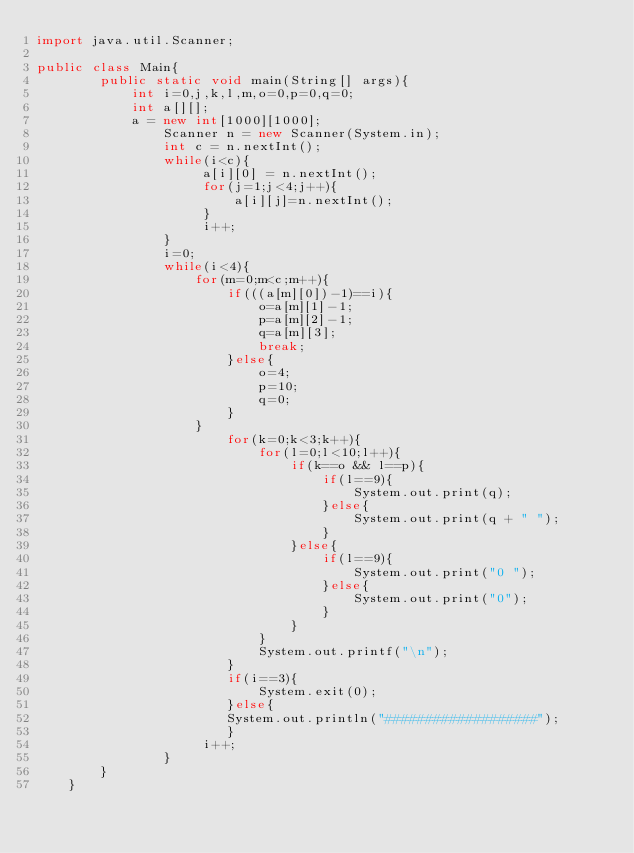Convert code to text. <code><loc_0><loc_0><loc_500><loc_500><_Java_>import java.util.Scanner;

public class Main{ 
        public static void main(String[] args){
            int i=0,j,k,l,m,o=0,p=0,q=0;
            int a[][];
            a = new int[1000][1000];
                Scanner n = new Scanner(System.in);
                int c = n.nextInt();
                while(i<c){
                     a[i][0] = n.nextInt();
                     for(j=1;j<4;j++){
                         a[i][j]=n.nextInt();
                     }
                     i++;
                }
                i=0;
                while(i<4){
                    for(m=0;m<c;m++){
                        if(((a[m][0])-1)==i){
                            o=a[m][1]-1;
                            p=a[m][2]-1;
                            q=a[m][3];
                            break;
                        }else{
                            o=4;
                            p=10;
                            q=0;
                        }
                    }
                        for(k=0;k<3;k++){
                            for(l=0;l<10;l++){
                                if(k==o && l==p){
                                    if(l==9){
                                        System.out.print(q);
                                    }else{
                                        System.out.print(q + " ");
                                    }
                                }else{
                                    if(l==9){
                                        System.out.print("0 ");
                                    }else{
                                        System.out.print("0");
                                    }
                                }
                            }
                            System.out.printf("\n");
                        }
                        if(i==3){
                            System.exit(0);
                        }else{
                        System.out.println("###################");
                        }
                     i++;
                }
        }
    }
</code> 